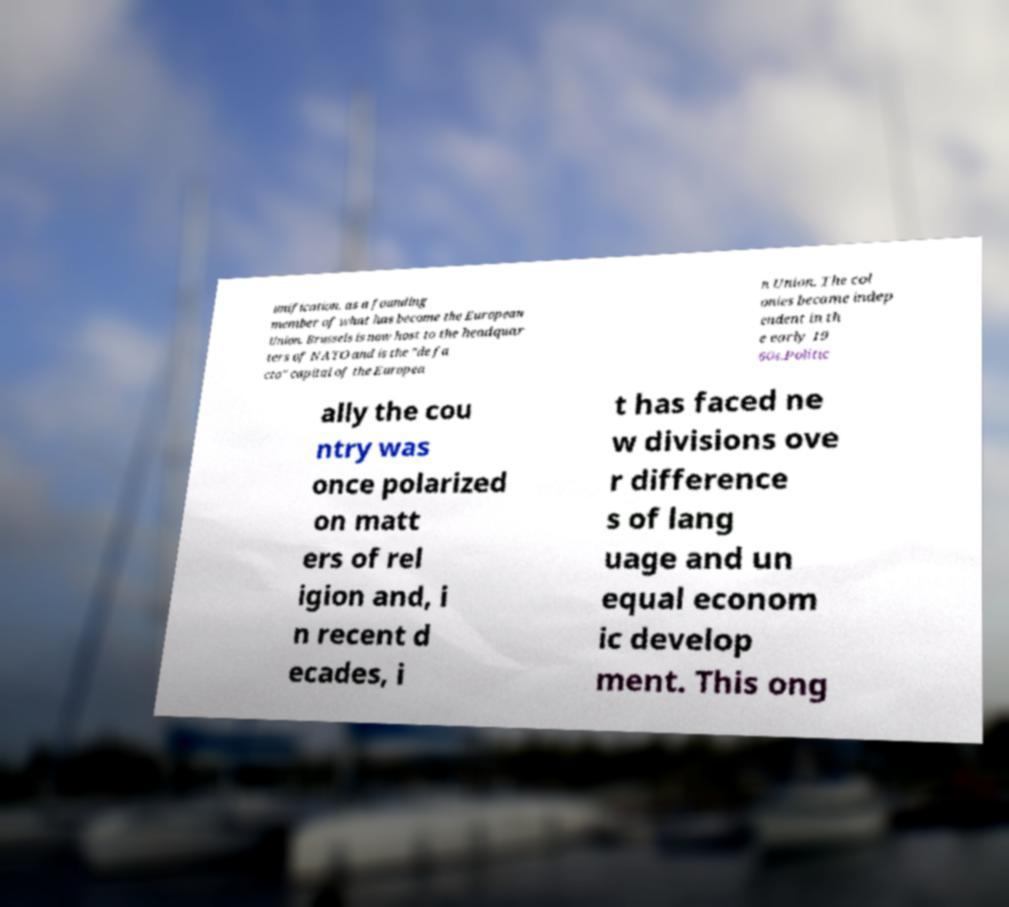Please identify and transcribe the text found in this image. unification, as a founding member of what has become the European Union. Brussels is now host to the headquar ters of NATO and is the "de fa cto" capital of the Europea n Union. The col onies became indep endent in th e early 19 60s.Politic ally the cou ntry was once polarized on matt ers of rel igion and, i n recent d ecades, i t has faced ne w divisions ove r difference s of lang uage and un equal econom ic develop ment. This ong 